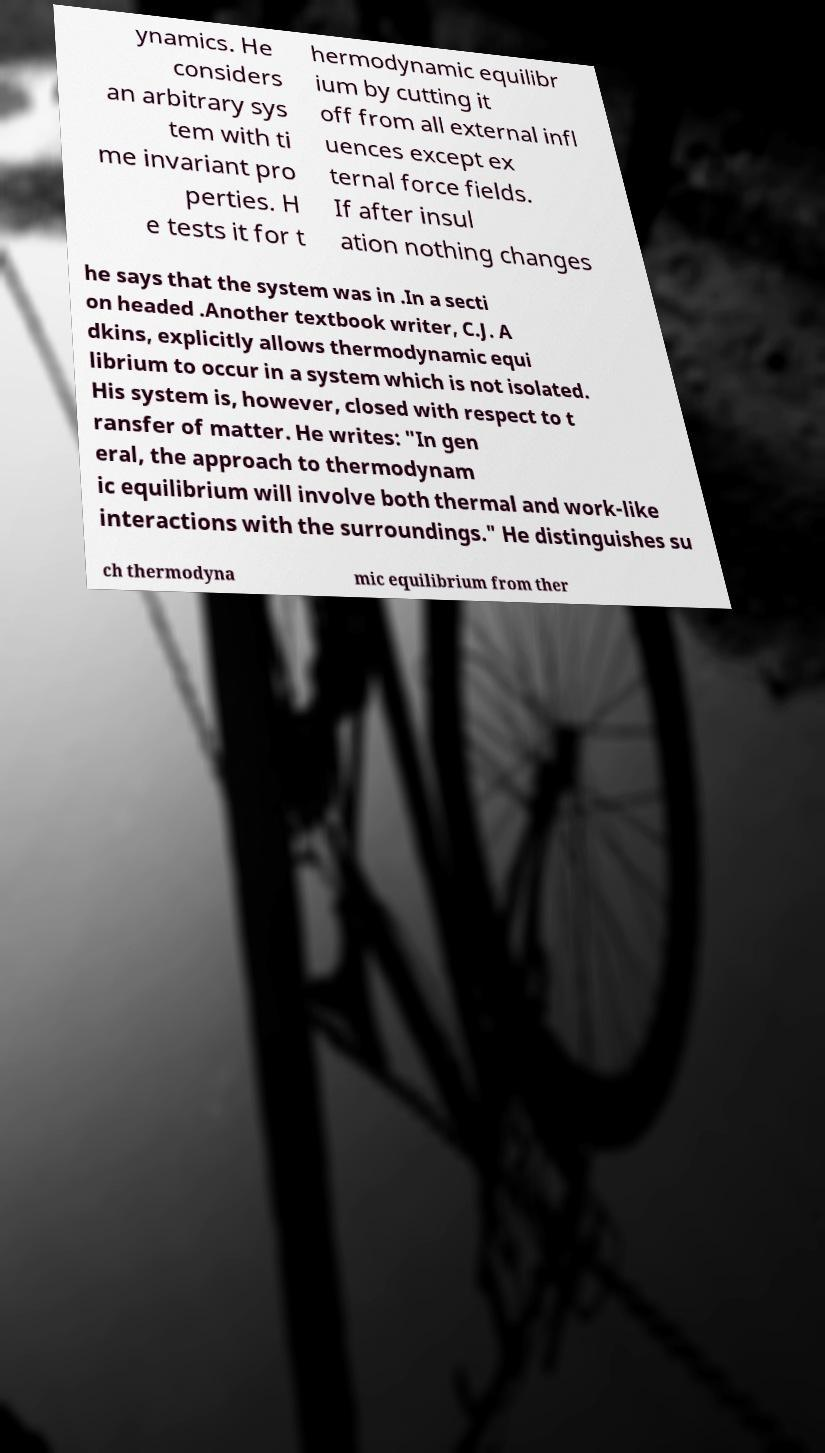Can you accurately transcribe the text from the provided image for me? ynamics. He considers an arbitrary sys tem with ti me invariant pro perties. H e tests it for t hermodynamic equilibr ium by cutting it off from all external infl uences except ex ternal force fields. If after insul ation nothing changes he says that the system was in .In a secti on headed .Another textbook writer, C.J. A dkins, explicitly allows thermodynamic equi librium to occur in a system which is not isolated. His system is, however, closed with respect to t ransfer of matter. He writes: "In gen eral, the approach to thermodynam ic equilibrium will involve both thermal and work-like interactions with the surroundings." He distinguishes su ch thermodyna mic equilibrium from ther 